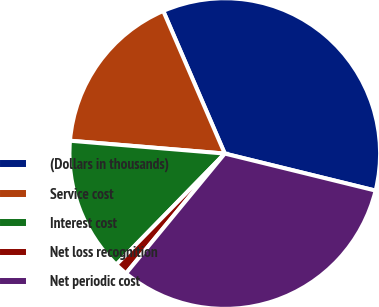Convert chart. <chart><loc_0><loc_0><loc_500><loc_500><pie_chart><fcel>(Dollars in thousands)<fcel>Service cost<fcel>Interest cost<fcel>Net loss recognition<fcel>Net periodic cost<nl><fcel>35.32%<fcel>17.2%<fcel>14.01%<fcel>1.34%<fcel>32.14%<nl></chart> 